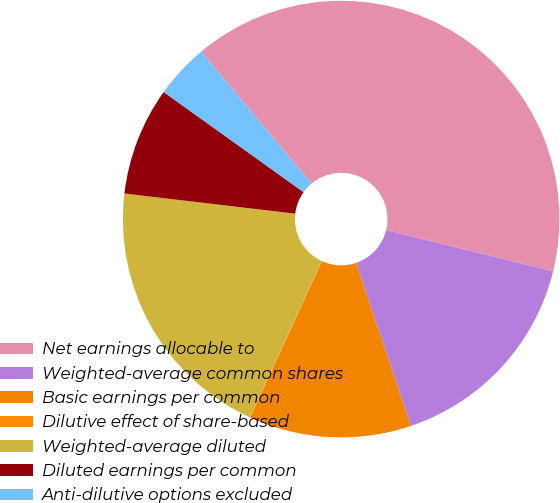<chart> <loc_0><loc_0><loc_500><loc_500><pie_chart><fcel>Net earnings allocable to<fcel>Weighted-average common shares<fcel>Basic earnings per common<fcel>Dilutive effect of share-based<fcel>Weighted-average diluted<fcel>Diluted earnings per common<fcel>Anti-dilutive options excluded<nl><fcel>39.91%<fcel>15.99%<fcel>12.01%<fcel>0.05%<fcel>19.98%<fcel>8.02%<fcel>4.04%<nl></chart> 